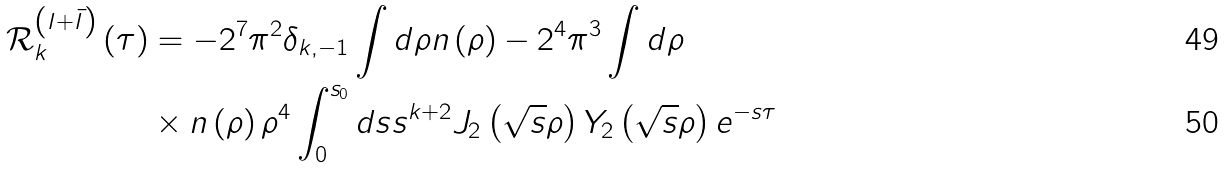Convert formula to latex. <formula><loc_0><loc_0><loc_500><loc_500>\mathcal { R } _ { k } ^ { \left ( I + \bar { I } \right ) } \left ( \tau \right ) & = - 2 ^ { 7 } \pi ^ { 2 } \delta _ { k , - 1 } \int d \rho n \left ( \rho \right ) - 2 ^ { 4 } \pi ^ { 3 } \int d \rho \\ & \times n \left ( \rho \right ) \rho ^ { 4 } \int _ { 0 } ^ { s _ { 0 } } d s s ^ { k + 2 } J _ { 2 } \left ( \sqrt { s } \rho \right ) Y _ { 2 } \left ( \sqrt { s } \rho \right ) e ^ { - s \tau }</formula> 